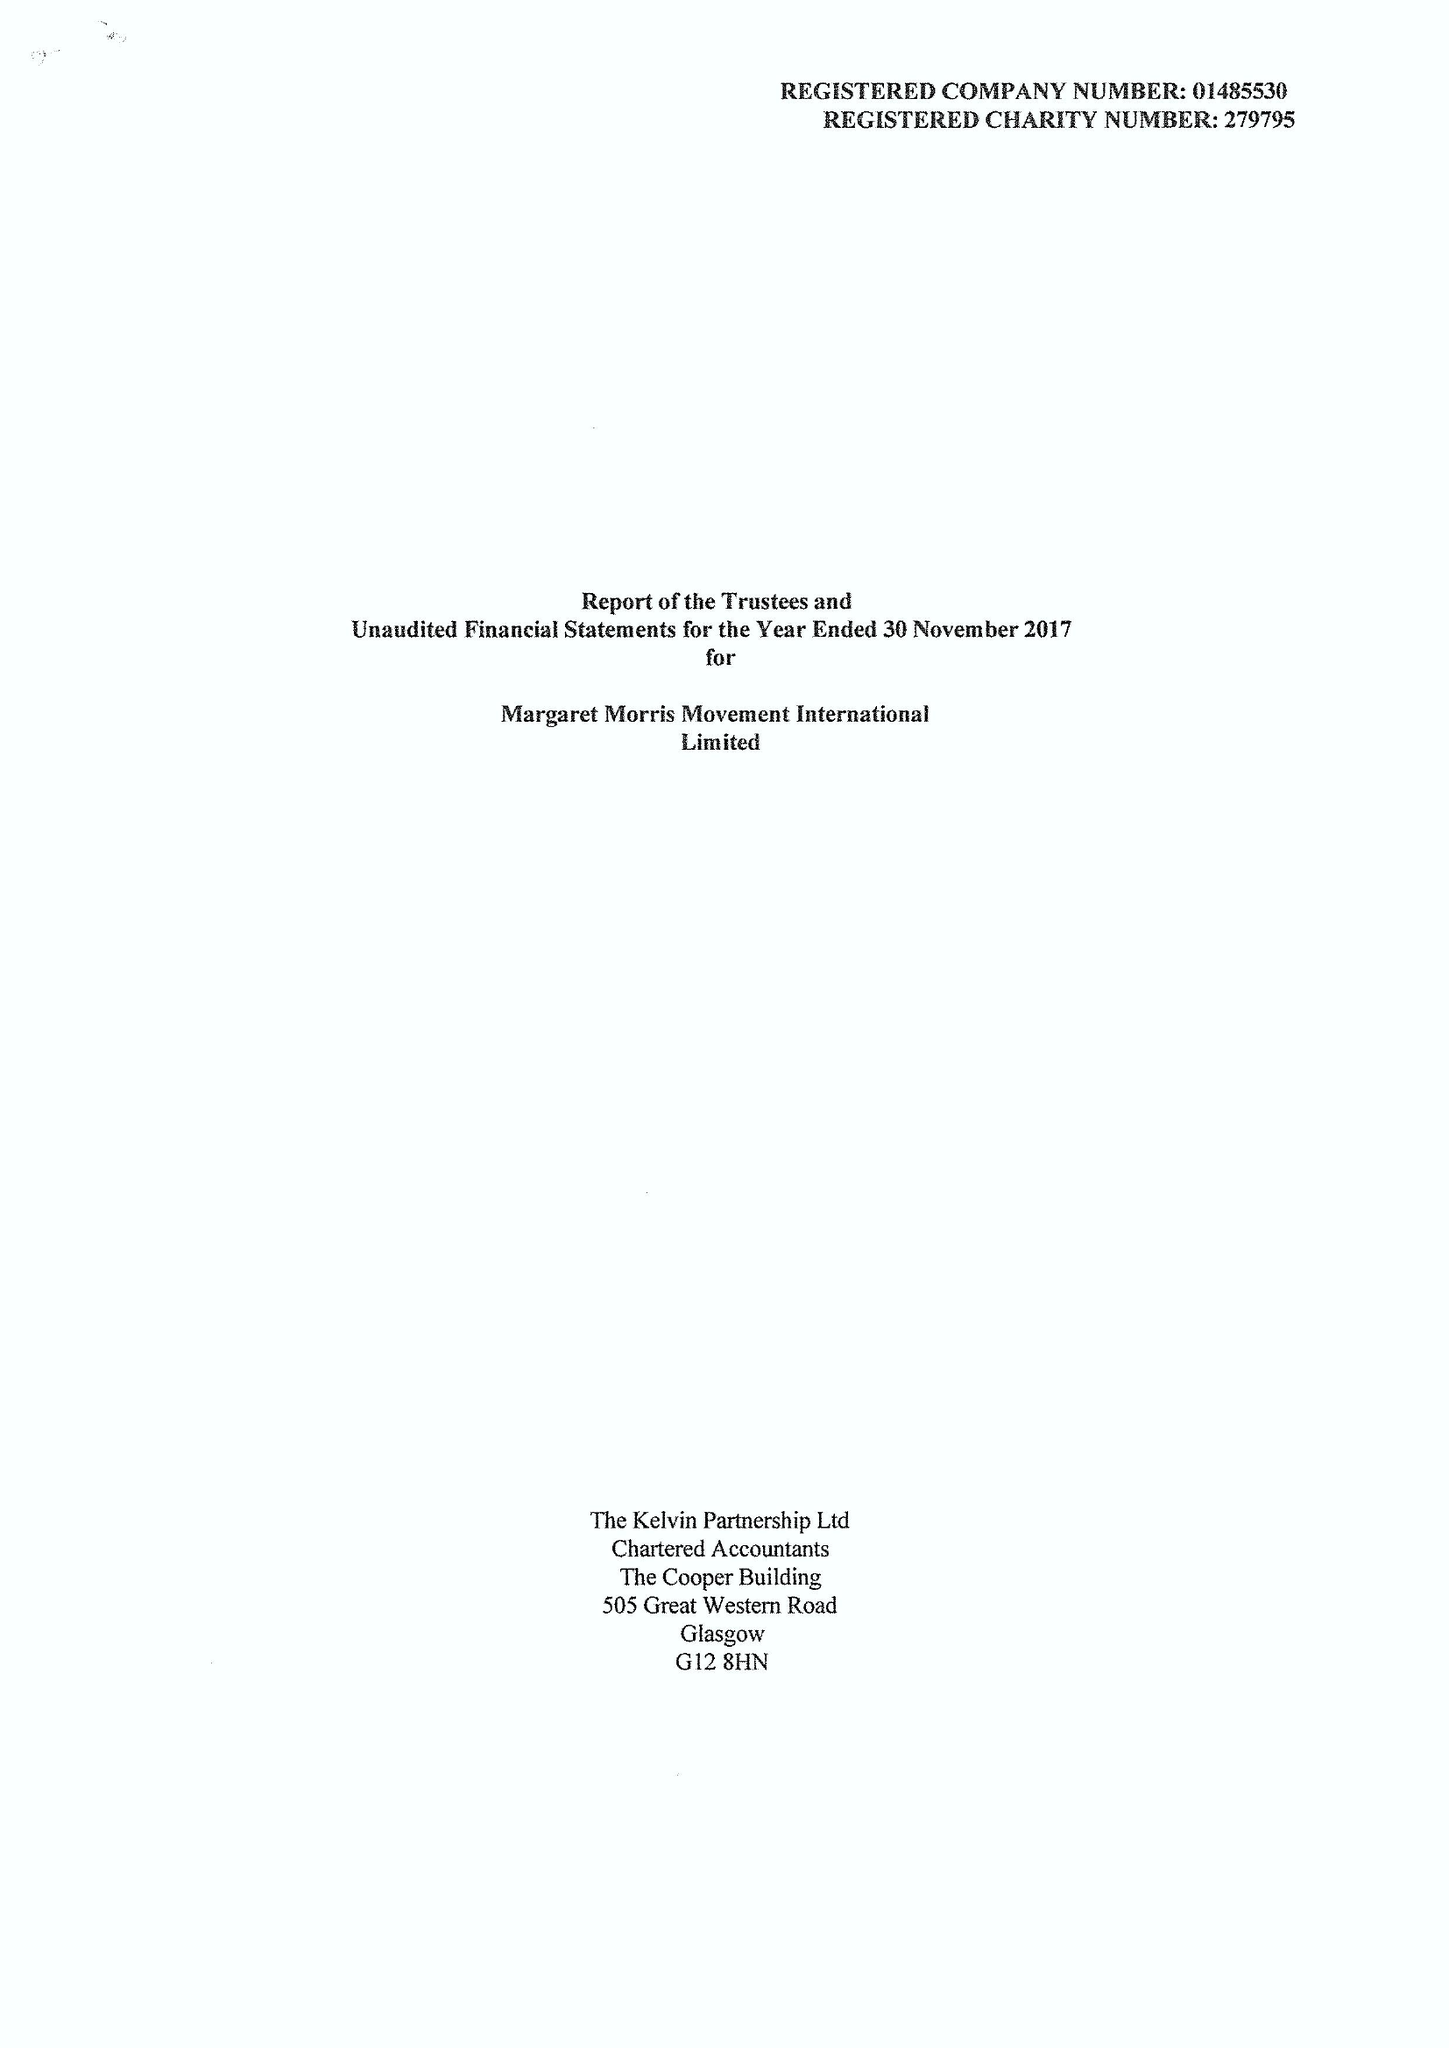What is the value for the report_date?
Answer the question using a single word or phrase. 2017-11-30 